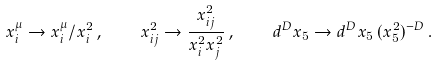Convert formula to latex. <formula><loc_0><loc_0><loc_500><loc_500>x _ { i } ^ { \mu } \to x _ { i } ^ { \mu } / x _ { i } ^ { 2 } \, , \quad x ^ { 2 } _ { i j } \to \frac { x ^ { 2 } _ { i j } } { x _ { i } ^ { 2 } x _ { j } ^ { 2 } } \, , \quad d ^ { D } x _ { 5 } \to d ^ { D } x _ { 5 } \, ( x _ { 5 } ^ { 2 } ) ^ { - D } \, .</formula> 